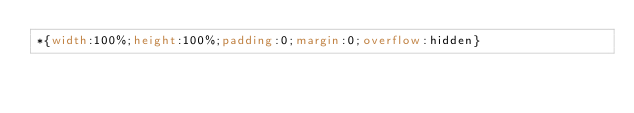<code> <loc_0><loc_0><loc_500><loc_500><_CSS_>*{width:100%;height:100%;padding:0;margin:0;overflow:hidden}</code> 